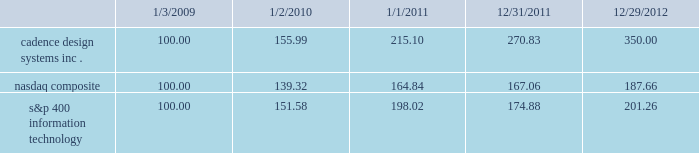The following graph compares the cumulative 4-year total stockholder return on our common stock relative to the cumulative total return of the nasdaq composite index and the s&p 400 information technology index .
The graph assumes that the value of the investment in our common stock and in each index ( including reinvestment of dividends ) was $ 100 on january 3 , 2009 and tracks it through december 29 , 2012 .
Comparison of 4 year cumulative total return* among cadence design systems , inc. , the nasdaq composite index , and s&p 400 information technology cadence design systems , inc .
Nasdaq composite s&p 400 information technology 12/29/121/1/11 12/31/111/2/101/3/09 *$ 100 invested on 1/3/09 in stock or 12/31/08 in index , including reinvestment of dividends .
Indexes calculated on month-end basis .
Copyright a9 2013 s&p , a division of the mcgraw-hill companies all rights reserved. .
The stock price performance included in this graph is not necessarily indicative of future stock price performance. .
What is the total return if $ 1000000 are invested in cadence design system in 2009 and sold in 2010? 
Computations: (((155.99 - 100) / 100) * 1000000)
Answer: 559900.0. 